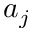<formula> <loc_0><loc_0><loc_500><loc_500>a _ { j }</formula> 